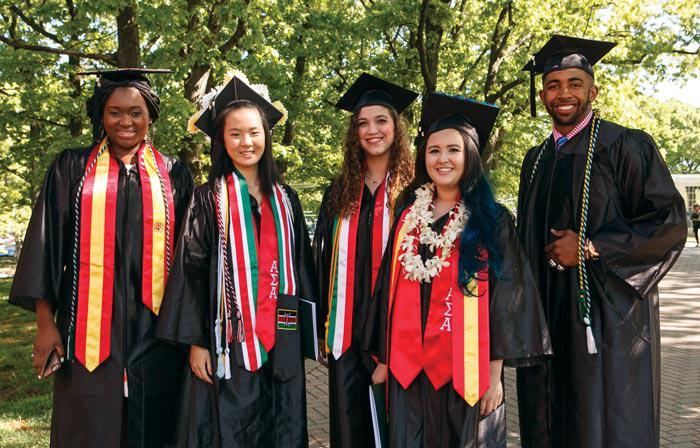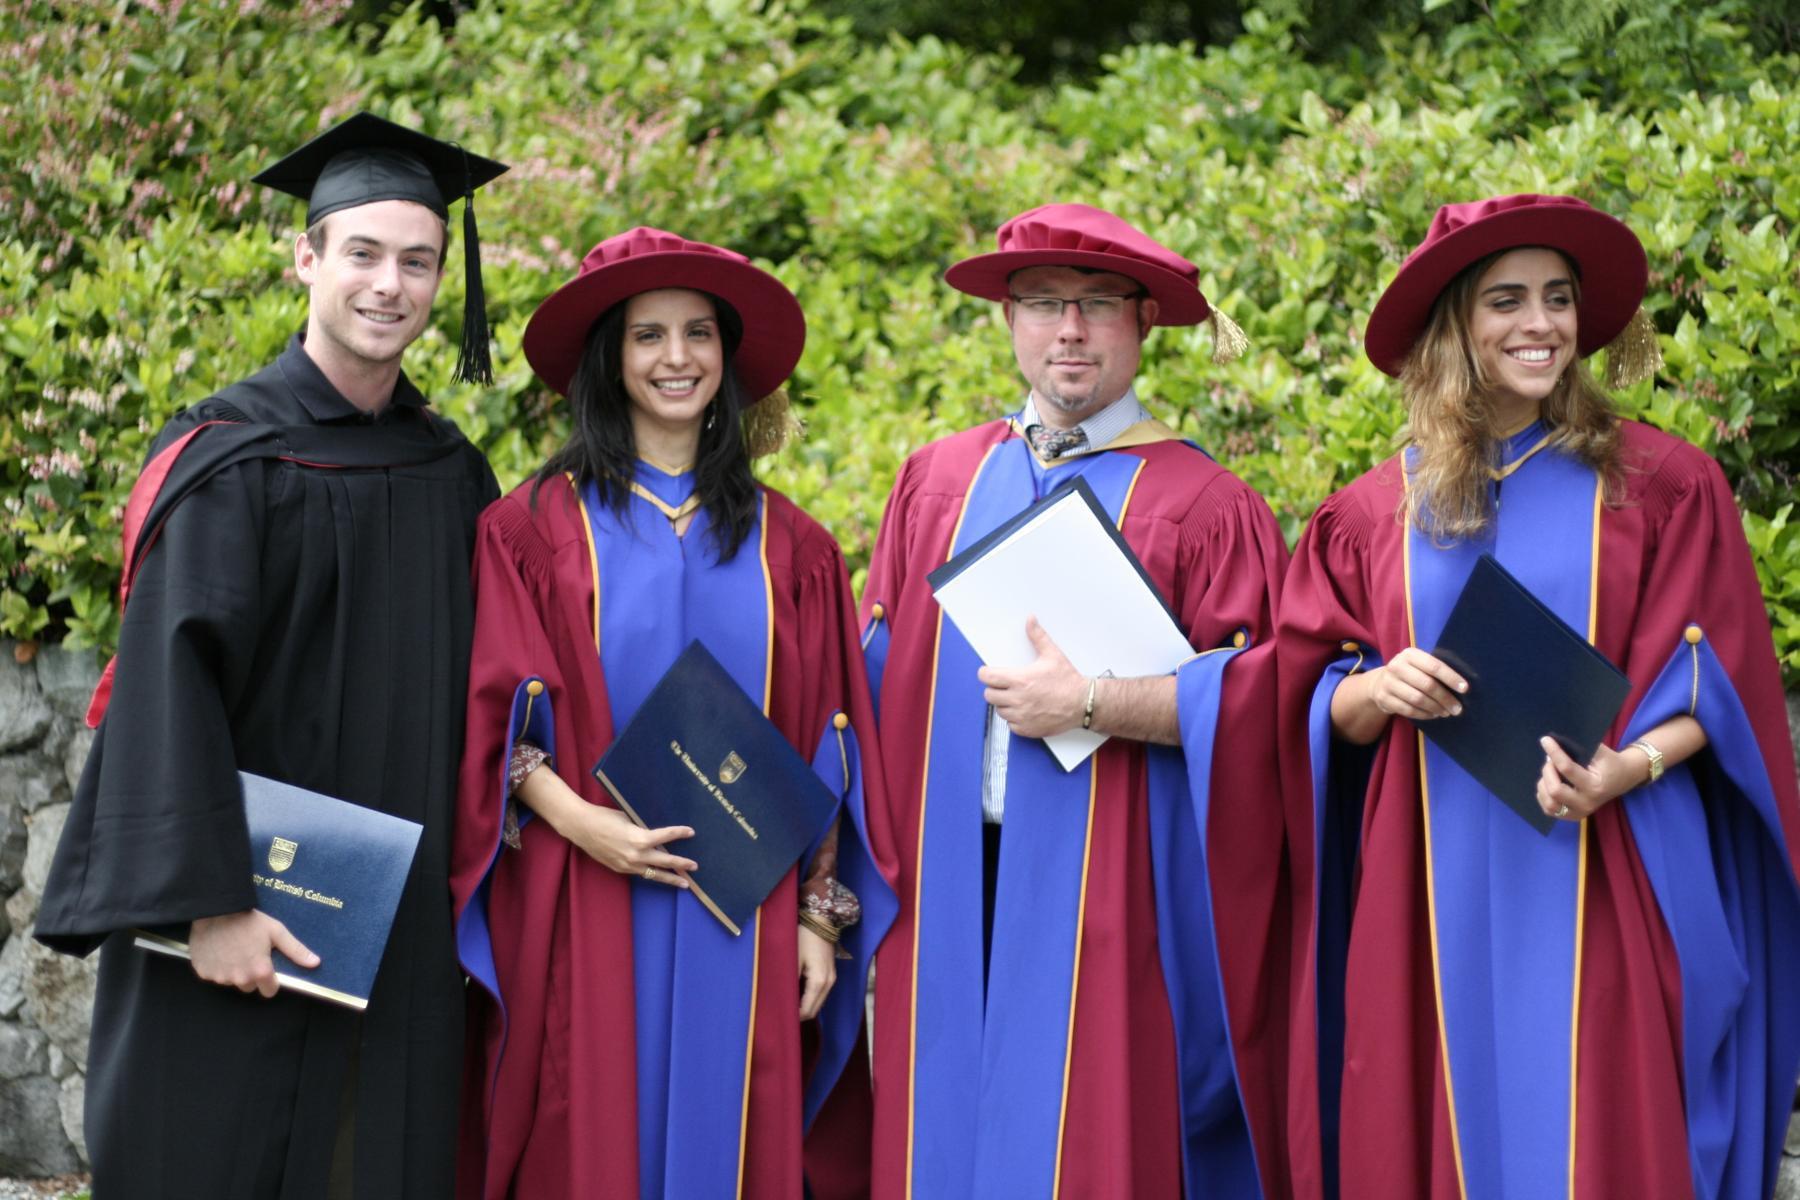The first image is the image on the left, the second image is the image on the right. Analyze the images presented: Is the assertion "One image has exactly four people in the foreground." valid? Answer yes or no. Yes. The first image is the image on the left, the second image is the image on the right. Considering the images on both sides, is "There is a single black male wearing a cap and gowns with a set of tassels hanging down around his neck." valid? Answer yes or no. Yes. 